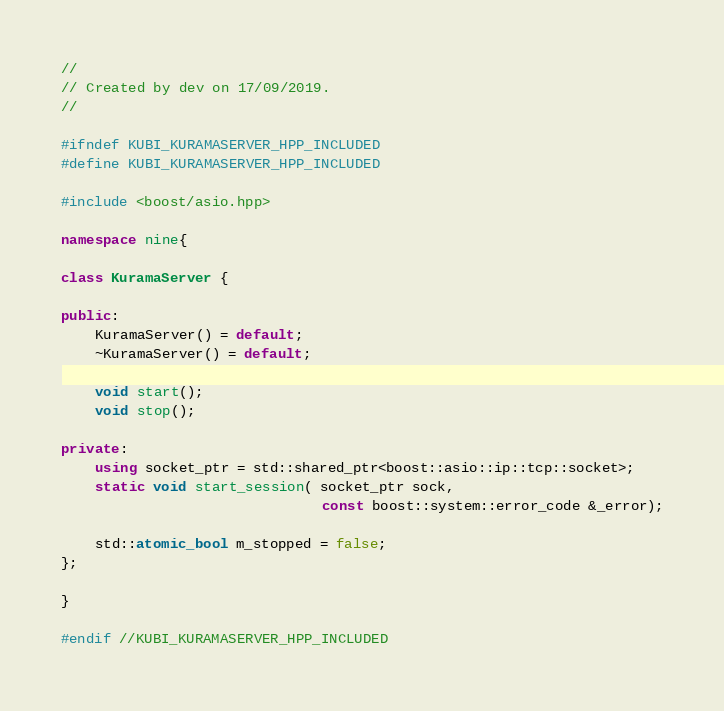Convert code to text. <code><loc_0><loc_0><loc_500><loc_500><_C++_>//
// Created by dev on 17/09/2019.
//

#ifndef KUBI_KURAMASERVER_HPP_INCLUDED
#define KUBI_KURAMASERVER_HPP_INCLUDED

#include <boost/asio.hpp>

namespace nine{

class KuramaServer {

public:
	KuramaServer() = default;
	~KuramaServer() = default;

	void start();
	void stop();

private:
	using socket_ptr = std::shared_ptr<boost::asio::ip::tcp::socket>;
	static void start_session( socket_ptr sock,
							   const boost::system::error_code &_error);

	std::atomic_bool m_stopped = false;
};

}

#endif //KUBI_KURAMASERVER_HPP_INCLUDED
</code> 